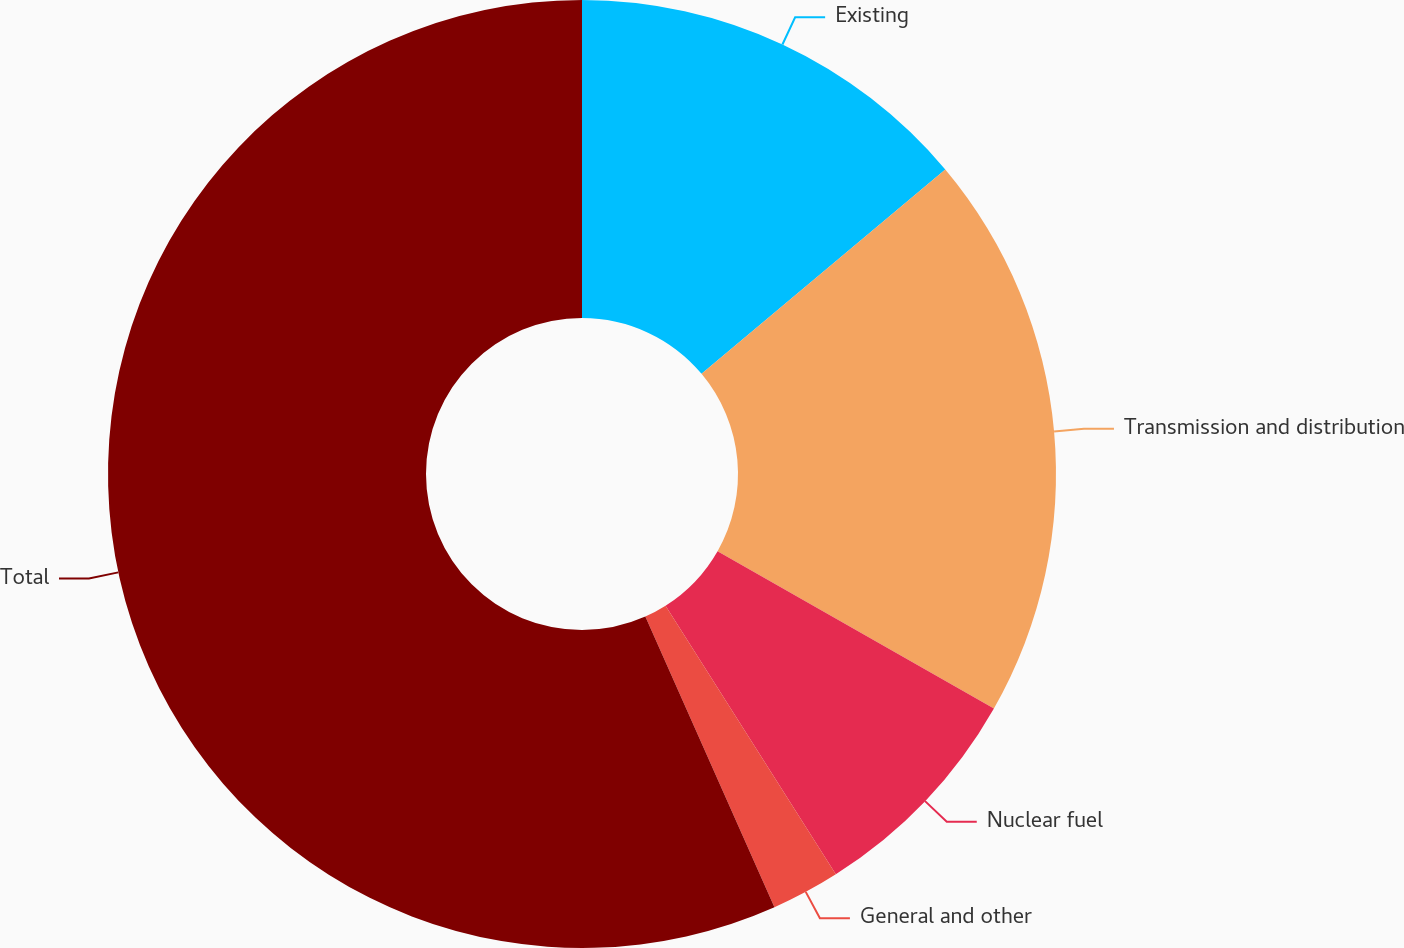Convert chart to OTSL. <chart><loc_0><loc_0><loc_500><loc_500><pie_chart><fcel>Existing<fcel>Transmission and distribution<fcel>Nuclear fuel<fcel>General and other<fcel>Total<nl><fcel>13.9%<fcel>19.34%<fcel>7.77%<fcel>2.34%<fcel>56.66%<nl></chart> 